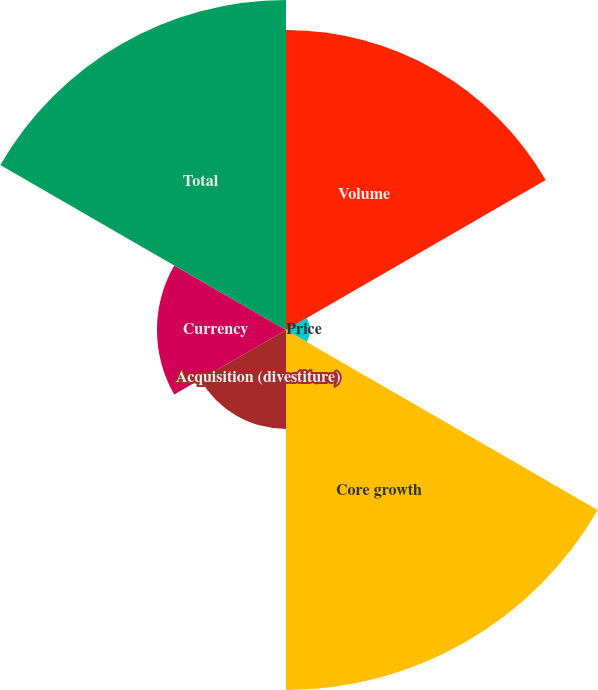Convert chart to OTSL. <chart><loc_0><loc_0><loc_500><loc_500><pie_chart><fcel>Volume<fcel>Price<fcel>Core growth<fcel>Acquisition (divestiture)<fcel>Currency<fcel>Total<nl><fcel>24.15%<fcel>1.93%<fcel>28.99%<fcel>7.97%<fcel>10.39%<fcel>26.57%<nl></chart> 